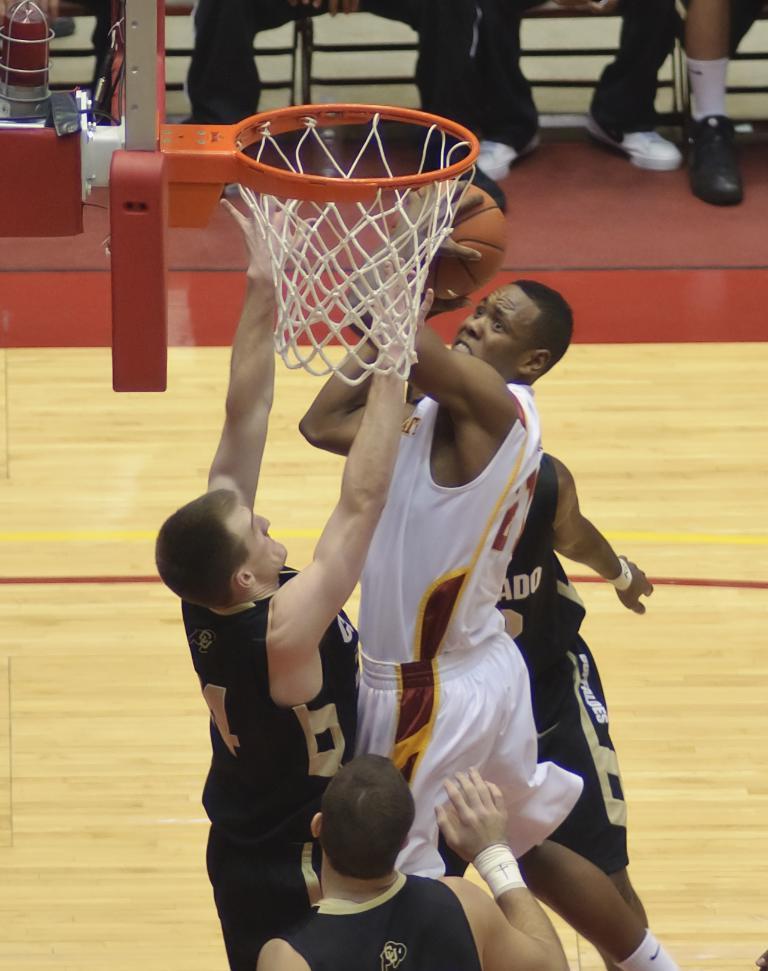Please provide a concise description of this image. This image is taken in a stadium where the persons are playing a game. On the top there is a basketball net and there is a person jumping holding a ball and in the background the legs of the persons are visible and on the left side there is an object which is red in colour. 